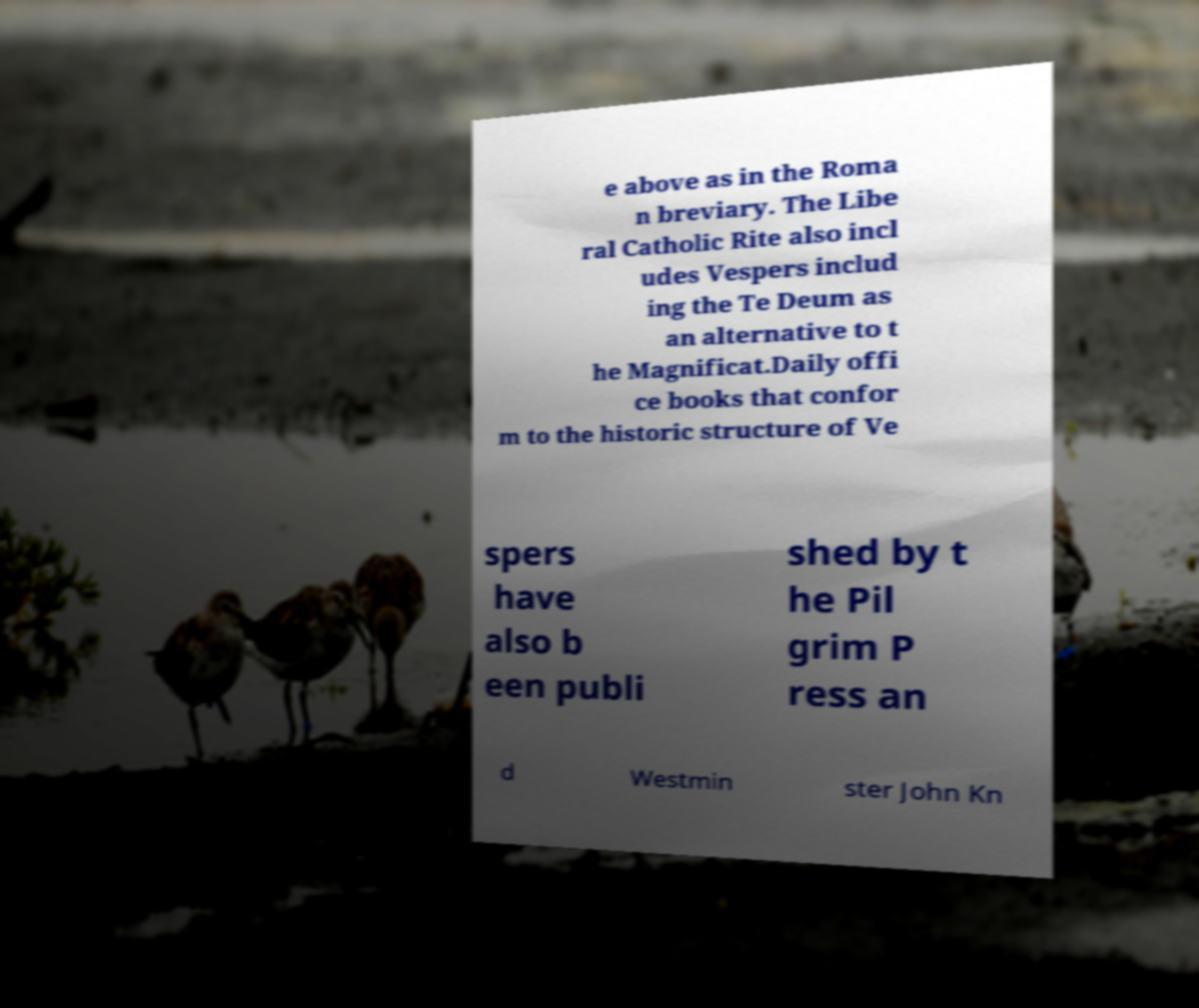What messages or text are displayed in this image? I need them in a readable, typed format. e above as in the Roma n breviary. The Libe ral Catholic Rite also incl udes Vespers includ ing the Te Deum as an alternative to t he Magnificat.Daily offi ce books that confor m to the historic structure of Ve spers have also b een publi shed by t he Pil grim P ress an d Westmin ster John Kn 